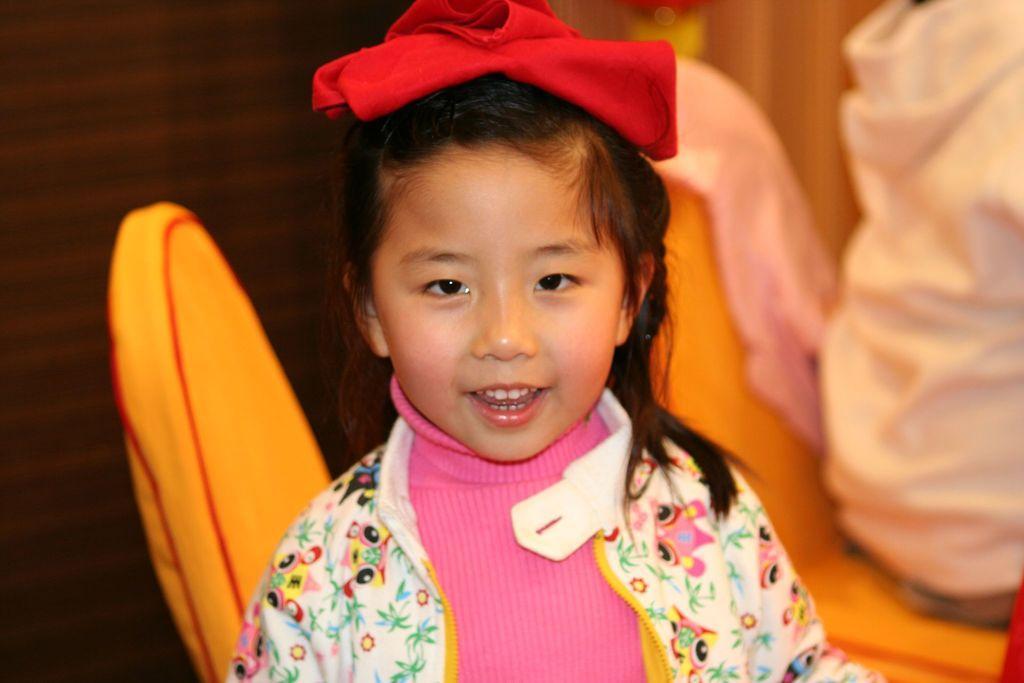Please provide a concise description of this image. In this given image, We can see a two chairs towards the right, We can see the person sitting in chair and in the middle, We can see a girl standing and a red colored cloth kept in her head. 